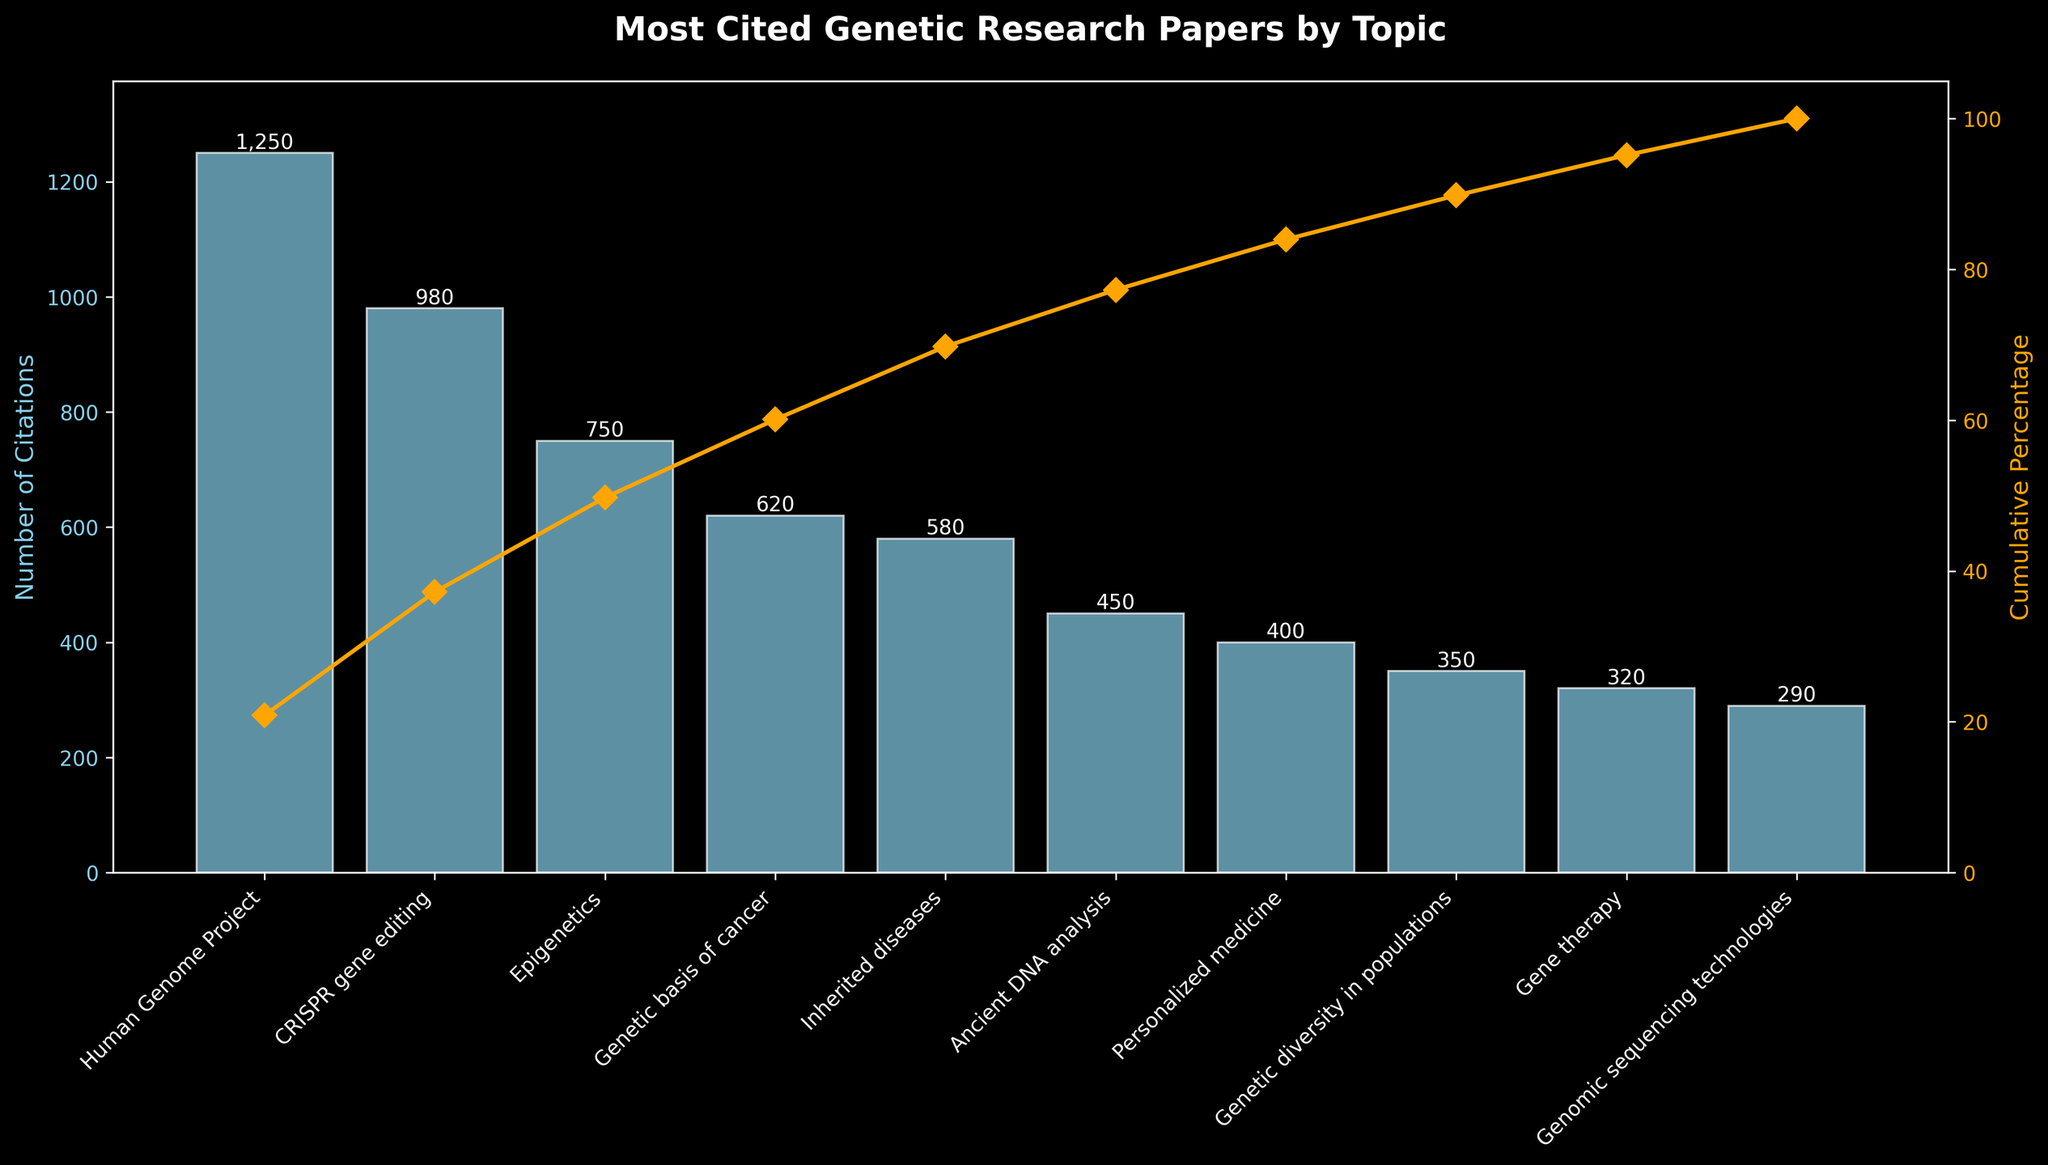Which topic has the highest number of citations? The topic with the highest bar represents the one with the most citations. According to the figure, the "Human Genome Project" has the tallest bar of 1250 citations.
Answer: Human Genome Project What's the cumulative percentage of citations for CRISPR gene editing? The cumulative percentage line plotted over the bar chart shows the cumulative percentage. Look at the point corresponding to "CRISPR gene editing" on this line; it should be around 63%.
Answer: Approximately 63% How many topics have more than 500 citations? Count the number of bars that exceed the 500-citation mark on the y-axis. According to the plot, 4 topics ("Human Genome Project," "CRISPR gene editing," "Epigenetics," and "Genetic basis of cancer") have more than 500 citations.
Answer: 4 Which topic is cited more: Gene therapy or Genomic sequencing technologies? Compare the heights of the bars corresponding to these two topics. "Gene therapy" has a taller bar with 320 citations, while "Genomic sequencing technologies" has 290 citations.
Answer: Gene therapy What fraction of total citations does Epigenetics contribute? Epigenetics has 750 citations. To find the fraction, divide 750 by the total number of citations and simplify the fraction. Total citations = 1250 + 980 + 750 + 620 + 580 + 450 + 400 + 350 + 320 + 290 = 5990. Fraction = 750/5990. Simplifying gives approximately 1/8.
Answer: Approximately 1/8 What is the difference in cumulative percentage between Ancient DNA analysis and Genetic basis of cancer? Determine the cumulative percentage for each from the chart (in this case for "Ancient DNA analysis" ~89% and "Genetic basis of cancer" ~70%), then subtract the values. Difference = 89% - 70% = 19%.
Answer: 19% What's the combined number of citations for the top two cited topics? Add the number of citations for "Human Genome Project" (1250) and "CRISPR gene editing" (980). Combined citations = 1250 + 980 = 2230.
Answer: 2230 What's the citation difference between Inherited diseases and Personalized medicine? Subtract the number of citations for "Personalized medicine" (400) from "Inherited diseases" (580). Difference = 580 - 400 = 180.
Answer: 180 What percentage of total citations is made up by topics with fewer than 400 citations? Summing the citations for topics with fewer than 400 citations: 350 (Genetic diversity in populations), 320 (Gene therapy), 290 (Genomic sequencing technologies). Total for these = 350 + 320 + 290 = 960. Percentage = (960/5990) * 100 ≈ 16%.
Answer: Approximately 16% What is the median number of citations across all topics? List the number of citations in ascending order: 290, 320, 350, 400, 450, 580, 620, 750, 980, 1250. The median is the average of the middle two values: (450+580)/2 = 515.
Answer: 515 